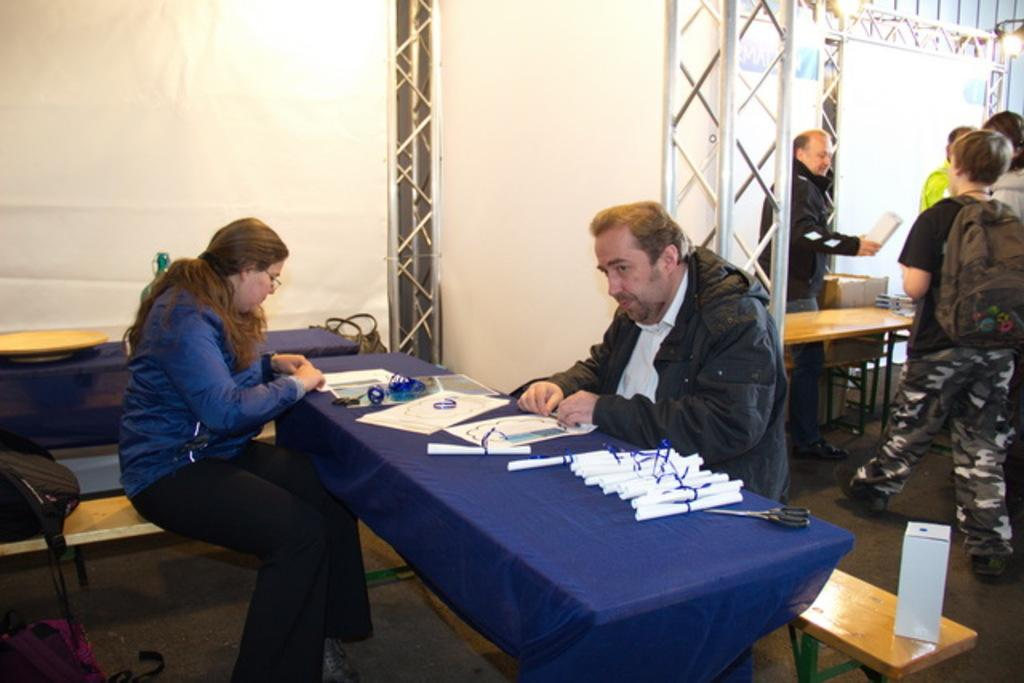What can be seen on one side of the image? There is a group of men standing at one side of the image. What are the men wearing? The men are wearing backpacks. What can be seen on the other side of the image? There is a man and a woman sitting at the other side of the image. Where are the man and woman sitting? The man and woman are sitting at tables. What is on the tables? There are papers on the tables. What is the position of the goldfish in the image? There is no goldfish present in the image. How long does it take for the minute to pass in the image? Time is not depicted in the image, so it is not possible to determine how long a minute takes. 